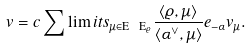<formula> <loc_0><loc_0><loc_500><loc_500>v = c \sum \lim i t s _ { \mu \in \mathrm E \ \mathrm E _ { \varrho } } \frac { \langle \varrho , \mu \rangle } { \langle \alpha ^ { \vee } , \mu \rangle } e _ { - \alpha } v _ { \mu } .</formula> 